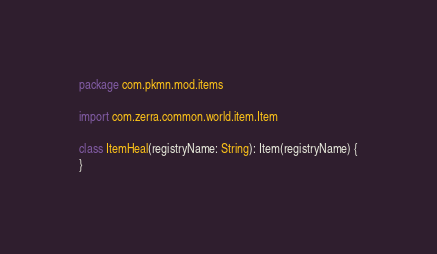<code> <loc_0><loc_0><loc_500><loc_500><_Kotlin_>package com.pkmn.mod.items

import com.zerra.common.world.item.Item

class ItemHeal(registryName: String): Item(registryName) {
}</code> 